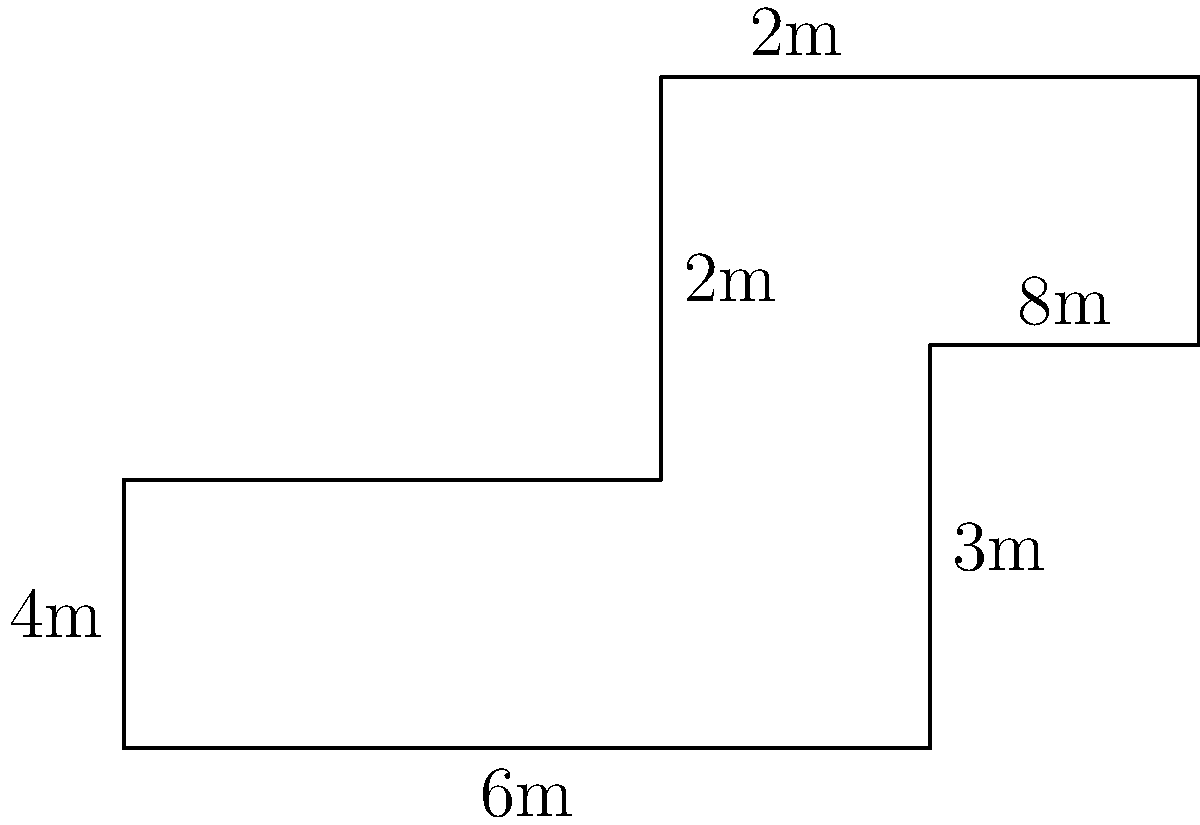In a haunted house, there's an oddly-shaped room as shown in the floor plan above. Calculate the total area of this room in square meters. To calculate the area of this oddly-shaped room, we can break it down into simpler geometric shapes:

1. Main rectangle:
   Length = 6m, Width = 2m
   Area = $6 \times 2 = 12$ sq m

2. Upper right rectangle:
   Length = 2m, Width = 2m
   Area = $2 \times 2 = 4$ sq m

3. Lower right rectangle:
   Length = 2m, Width = 3m
   Area = $2 \times 3 = 6$ sq m

Now, we sum up the areas of these three rectangles:

Total Area = $12 + 4 + 6 = 22$ sq m

Therefore, the total area of the oddly-shaped room is 22 square meters.
Answer: 22 sq m 